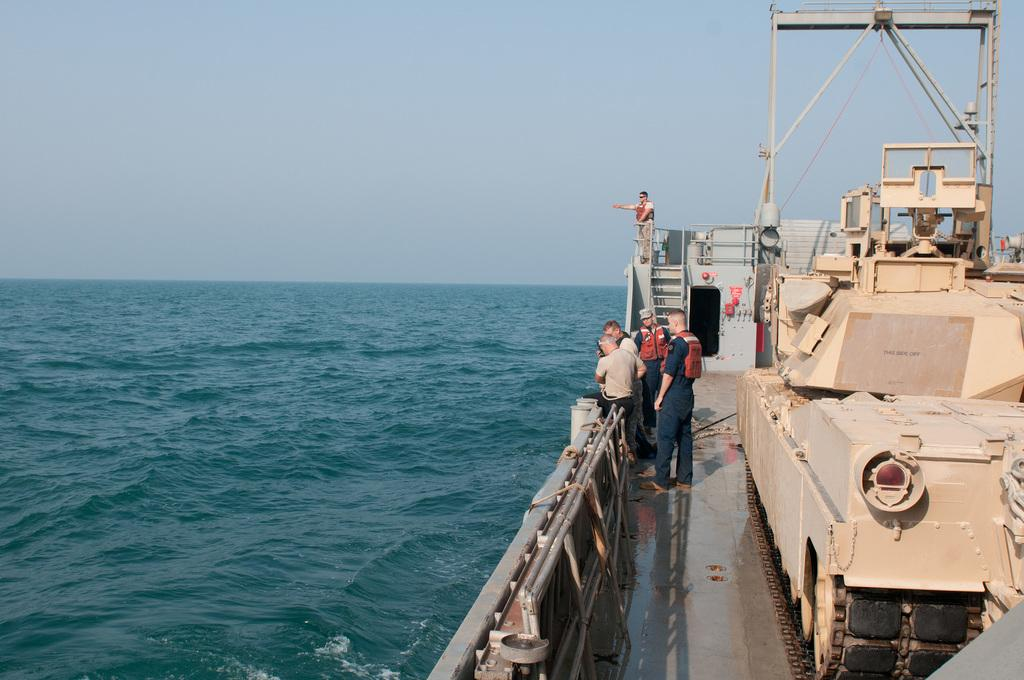What can be seen on the right side of the image? There are persons in a ship on the right side of the image. What is visible in the background of the image? There is water and the sky visible in the background of the image. What type of alley can be seen in the image? There is no alley present in the image; it features a ship on the water. 